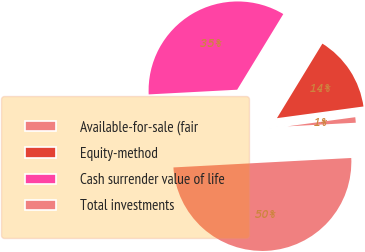<chart> <loc_0><loc_0><loc_500><loc_500><pie_chart><fcel>Available-for-sale (fair<fcel>Equity-method<fcel>Cash surrender value of life<fcel>Total investments<nl><fcel>1.29%<fcel>14.15%<fcel>34.56%<fcel>50.0%<nl></chart> 